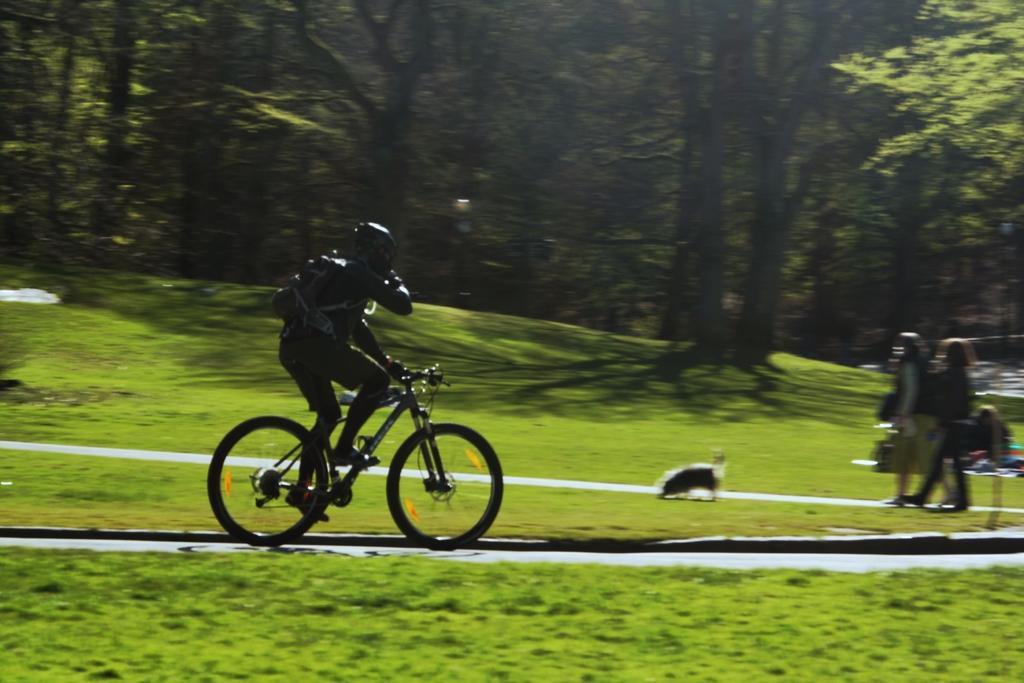How would you summarize this image in a sentence or two? In this image there is a person riding a bicycle on the road and at the back there are two persons are walking and there is a dog standing in the middle of the image. At the back there are trees, at the bottom there is a grass. 